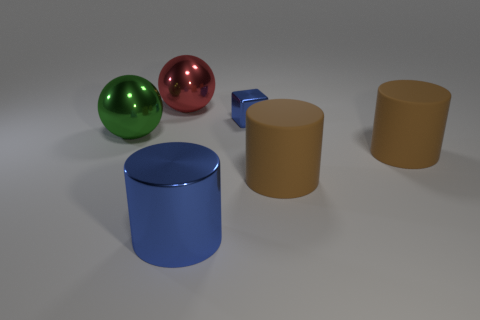Subtract all brown cylinders. How many were subtracted if there are1brown cylinders left? 1 Subtract all spheres. How many objects are left? 4 Subtract 2 balls. How many balls are left? 0 Subtract all brown cylinders. Subtract all cyan blocks. How many cylinders are left? 1 Subtract all purple blocks. How many red spheres are left? 1 Subtract all large green spheres. Subtract all red metallic spheres. How many objects are left? 4 Add 1 big brown cylinders. How many big brown cylinders are left? 3 Add 2 large spheres. How many large spheres exist? 4 Add 2 small yellow rubber cylinders. How many objects exist? 8 Subtract all green spheres. How many spheres are left? 1 